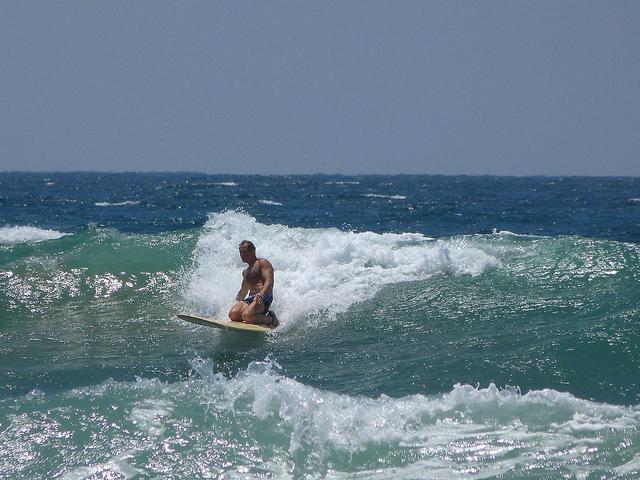Why is the man kneeling on a surfboard?
Be succinct. Surfing. Is the man wearing a shirt?
Give a very brief answer. No. What is the surfer wearing?
Keep it brief. Shorts. Are the waves big?
Give a very brief answer. No. 